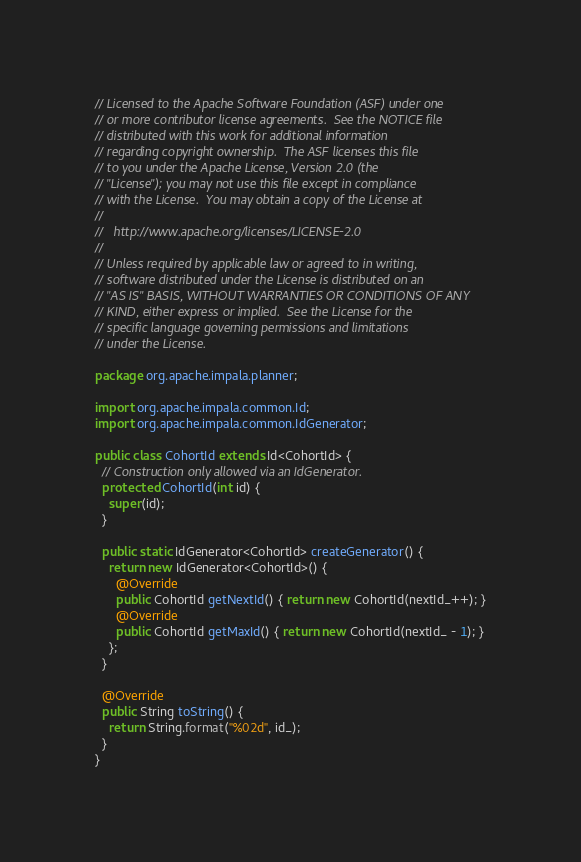<code> <loc_0><loc_0><loc_500><loc_500><_Java_>// Licensed to the Apache Software Foundation (ASF) under one
// or more contributor license agreements.  See the NOTICE file
// distributed with this work for additional information
// regarding copyright ownership.  The ASF licenses this file
// to you under the Apache License, Version 2.0 (the
// "License"); you may not use this file except in compliance
// with the License.  You may obtain a copy of the License at
//
//   http://www.apache.org/licenses/LICENSE-2.0
//
// Unless required by applicable law or agreed to in writing,
// software distributed under the License is distributed on an
// "AS IS" BASIS, WITHOUT WARRANTIES OR CONDITIONS OF ANY
// KIND, either express or implied.  See the License for the
// specific language governing permissions and limitations
// under the License.

package org.apache.impala.planner;

import org.apache.impala.common.Id;
import org.apache.impala.common.IdGenerator;

public class CohortId extends Id<CohortId> {
  // Construction only allowed via an IdGenerator.
  protected CohortId(int id) {
    super(id);
  }

  public static IdGenerator<CohortId> createGenerator() {
    return new IdGenerator<CohortId>() {
      @Override
      public CohortId getNextId() { return new CohortId(nextId_++); }
      @Override
      public CohortId getMaxId() { return new CohortId(nextId_ - 1); }
    };
  }

  @Override
  public String toString() {
    return String.format("%02d", id_);
  }
}
</code> 